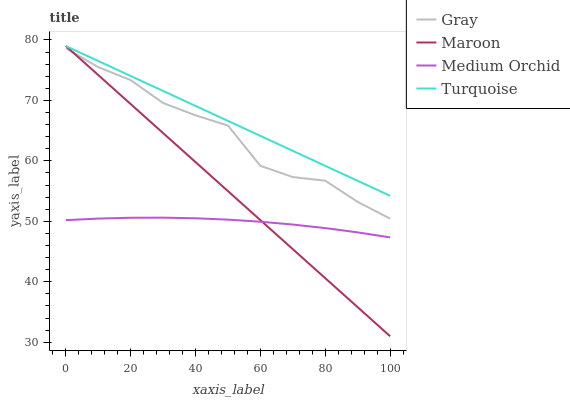Does Turquoise have the minimum area under the curve?
Answer yes or no. No. Does Medium Orchid have the maximum area under the curve?
Answer yes or no. No. Is Turquoise the smoothest?
Answer yes or no. No. Is Turquoise the roughest?
Answer yes or no. No. Does Medium Orchid have the lowest value?
Answer yes or no. No. Does Medium Orchid have the highest value?
Answer yes or no. No. Is Medium Orchid less than Turquoise?
Answer yes or no. Yes. Is Turquoise greater than Gray?
Answer yes or no. Yes. Does Medium Orchid intersect Turquoise?
Answer yes or no. No. 